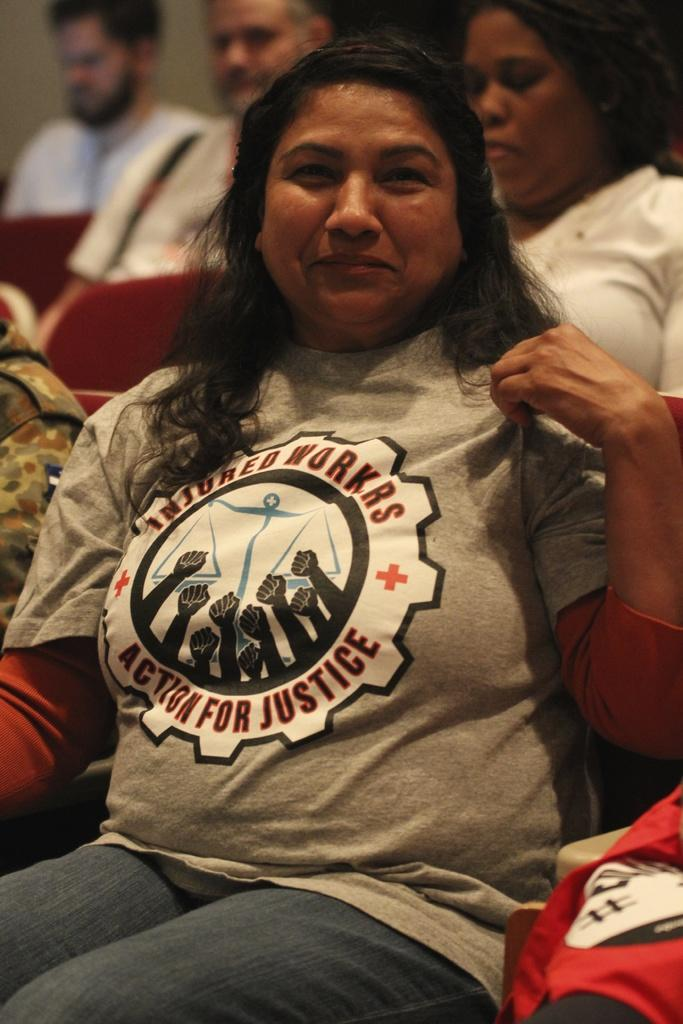Provide a one-sentence caption for the provided image. A hispanic woman is sitting and wears a shirt that says "Insured Workers, Action for Justice". 